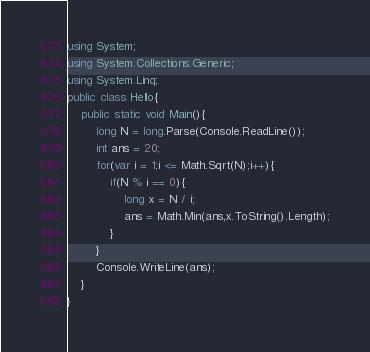<code> <loc_0><loc_0><loc_500><loc_500><_C#_>using System;
using System.Collections.Generic;
using System.Linq;
public class Hello{
    public static void Main(){
        long N = long.Parse(Console.ReadLine());
        int ans = 20;
        for(var i = 1;i <= Math.Sqrt(N);i++){
            if(N % i == 0){
                long x = N / i;
                ans = Math.Min(ans,x.ToString().Length);
            }
        }
        Console.WriteLine(ans);
    }
}
</code> 